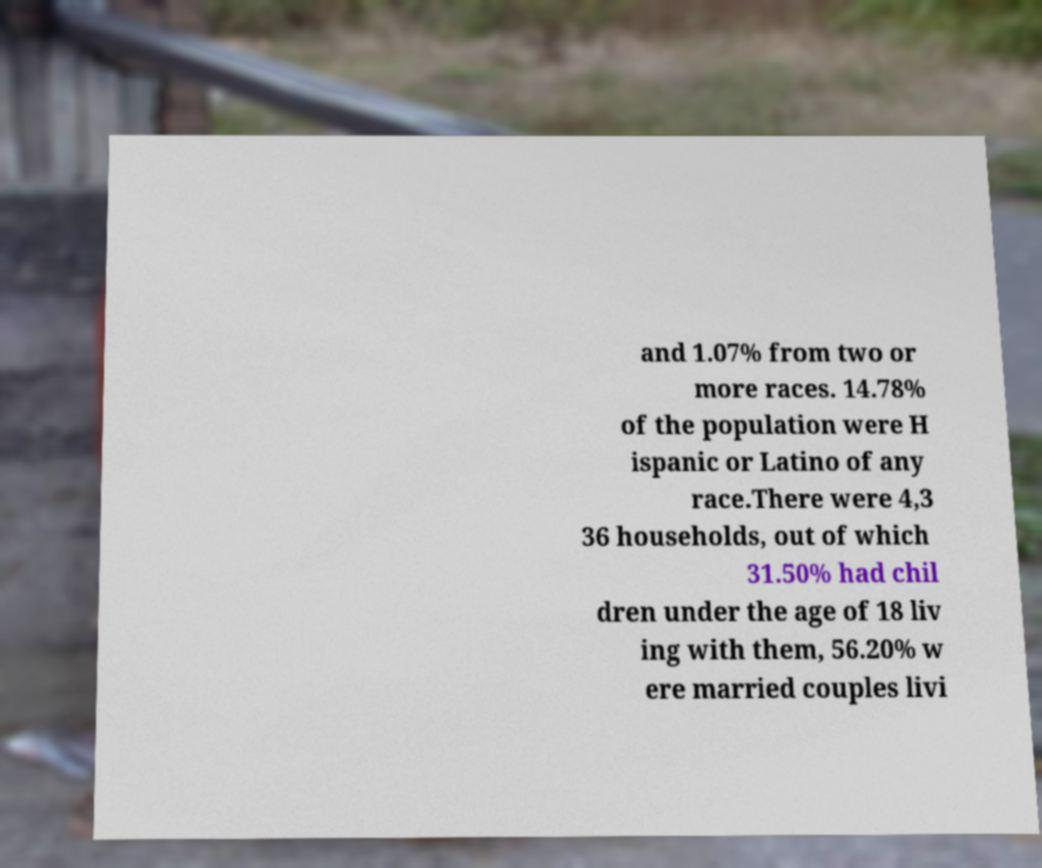I need the written content from this picture converted into text. Can you do that? and 1.07% from two or more races. 14.78% of the population were H ispanic or Latino of any race.There were 4,3 36 households, out of which 31.50% had chil dren under the age of 18 liv ing with them, 56.20% w ere married couples livi 